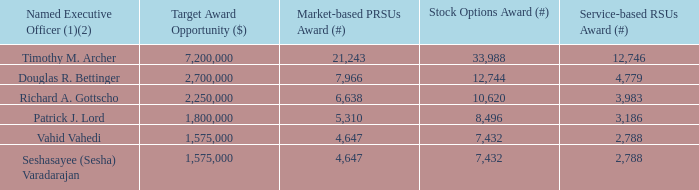Figure 31. 2019/2021 LTIP Award Grants
(1) The number of Market-based PRSUs awarded is reflected at target. The final number of shares that may be earned will be 0% to 150% of target.
(2) Mr. Anstice did not participate in the 2019/2021 LTIP because he terminated his employment with the Company as of December 5, 2018.
The independent members of the Board consulted with the committee and the committee’s compensation consultant to determine the appropriate amount and vesting schedule for Mr. Archer’s award. The independent members of the Board, on December 6, 2018, granted to Mr. Archer a $5,000,000 equity award consisting of 50% service-based RSUs and 50% stock options with a four-year vesting schedule, as shown below. No adjustment was made at that time to his annual base salary or his target award opportunities under the AIP or LTIP. These were adjusted to be competitive with CEOs in our peer group as part of the normal annual compensation review in February 2019.
In light of Mr. Bettinger’s critical role, his expanded responsibilities, and the intense competition in the technology industry for proven CFO talent, he received a special equity award on November 30, 2018. The committee consulted with its compensation consultant and with the Board to determine the amount and vesting schedule for the award. The committee granted to Mr. Bettinger a one-time service-based restricted stock unit (RSU) award with a nominal value of $8,000,000 and a four-year vesting schedule, as shown below.
What did the committee grant Mr Bettinger? A one-time service-based restricted stock unit (rsu) award with a nominal value of $8,000,000 and a four-year vesting schedule. What did the independent members of the Board grant Mr Archer on December 6, 2018? A $5,000,000 equity award consisting of 50% service-based rsus, 50% stock options with a four-year vesting schedule. Why did Mr Anstice not participate in the 2019/2021 LTIP? He terminated his employment with the company as of december 5, 2018. Which named executive officer has the highest Service-based RSUs Award? Find the named executive officer with the highest Service-based RSUs Award
Answer: timothy m. archer. Which named executive officer has the highest Stock Options Award? Find the named executive with the highest Stock Options Award
Answer: timothy m. archer. Which named executive officer has the highest Target Award Opportunity? Find the named executive officer with the highest Target Award Opportunity
Answer: timothy m. archer. 